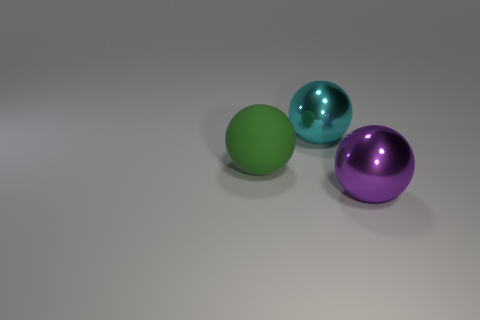How many things are either large rubber balls that are left of the purple sphere or objects that are behind the matte object?
Ensure brevity in your answer.  2. How many large green matte things have the same shape as the cyan metallic object?
Keep it short and to the point. 1. The metallic sphere that is the same size as the cyan metal thing is what color?
Keep it short and to the point. Purple. There is a object that is on the left side of the metal thing left of the large thing that is in front of the large green sphere; what color is it?
Provide a succinct answer. Green. Is the size of the purple sphere the same as the thing on the left side of the large cyan metal ball?
Keep it short and to the point. Yes. What number of objects are either metal objects or large yellow matte cylinders?
Offer a terse response. 2. Are there any large purple objects made of the same material as the large cyan object?
Offer a very short reply. Yes. The metallic sphere that is to the left of the metal sphere that is in front of the large green rubber object is what color?
Give a very brief answer. Cyan. Do the cyan sphere and the green rubber object have the same size?
Your answer should be very brief. Yes. How many spheres are either matte things or large cyan things?
Your answer should be compact. 2. 